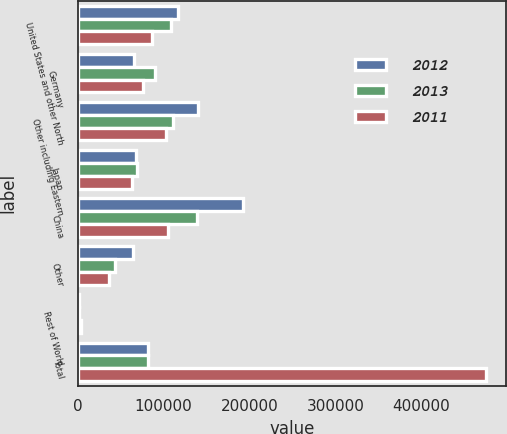Convert chart to OTSL. <chart><loc_0><loc_0><loc_500><loc_500><stacked_bar_chart><ecel><fcel>United States and other North<fcel>Germany<fcel>Other including Eastern<fcel>Japan<fcel>China<fcel>Other<fcel>Rest of World<fcel>Total<nl><fcel>2012<fcel>116935<fcel>65147<fcel>140279<fcel>67981<fcel>192134<fcel>64346<fcel>1212<fcel>81230<nl><fcel>2013<fcel>108316<fcel>89848<fcel>110860<fcel>69576<fcel>138782<fcel>43445<fcel>1701<fcel>81230<nl><fcel>2011<fcel>86181<fcel>76279<fcel>103305<fcel>63261<fcel>104560<fcel>36937<fcel>3959<fcel>474482<nl></chart> 